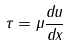Convert formula to latex. <formula><loc_0><loc_0><loc_500><loc_500>\tau = \mu \frac { d u } { d x }</formula> 